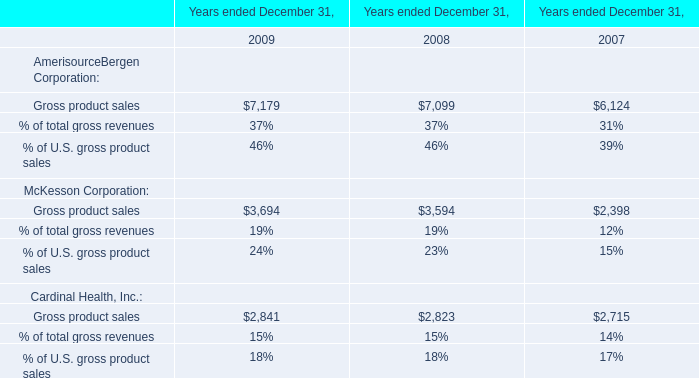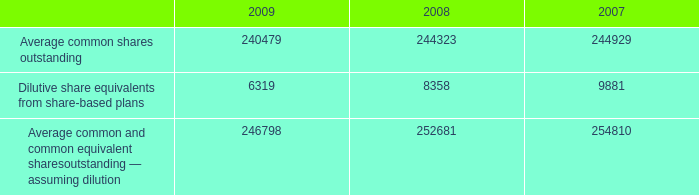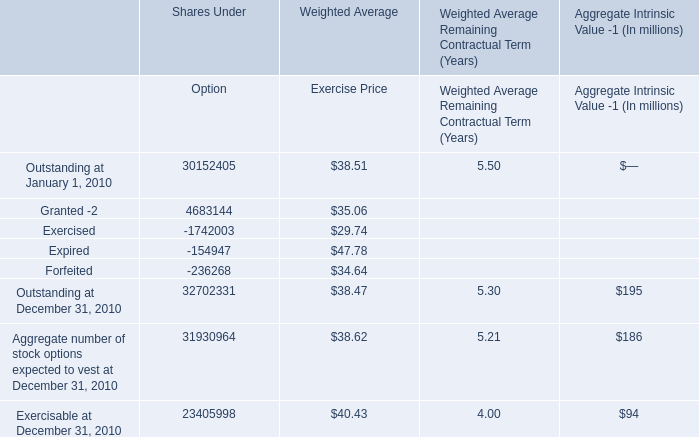What is the average amount of Average common shares outstanding of 2008, and Outstanding at January 1, 2010 of Shares Under Option ? 
Computations: ((244323.0 + 30152405.0) / 2)
Answer: 15198364.0. 